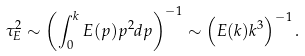Convert formula to latex. <formula><loc_0><loc_0><loc_500><loc_500>\tau _ { E } ^ { 2 } \sim \left ( \int _ { 0 } ^ { k } E ( p ) p ^ { 2 } d p \right ) ^ { - 1 } \sim \left ( E ( k ) k ^ { 3 } \right ) ^ { - 1 } .</formula> 